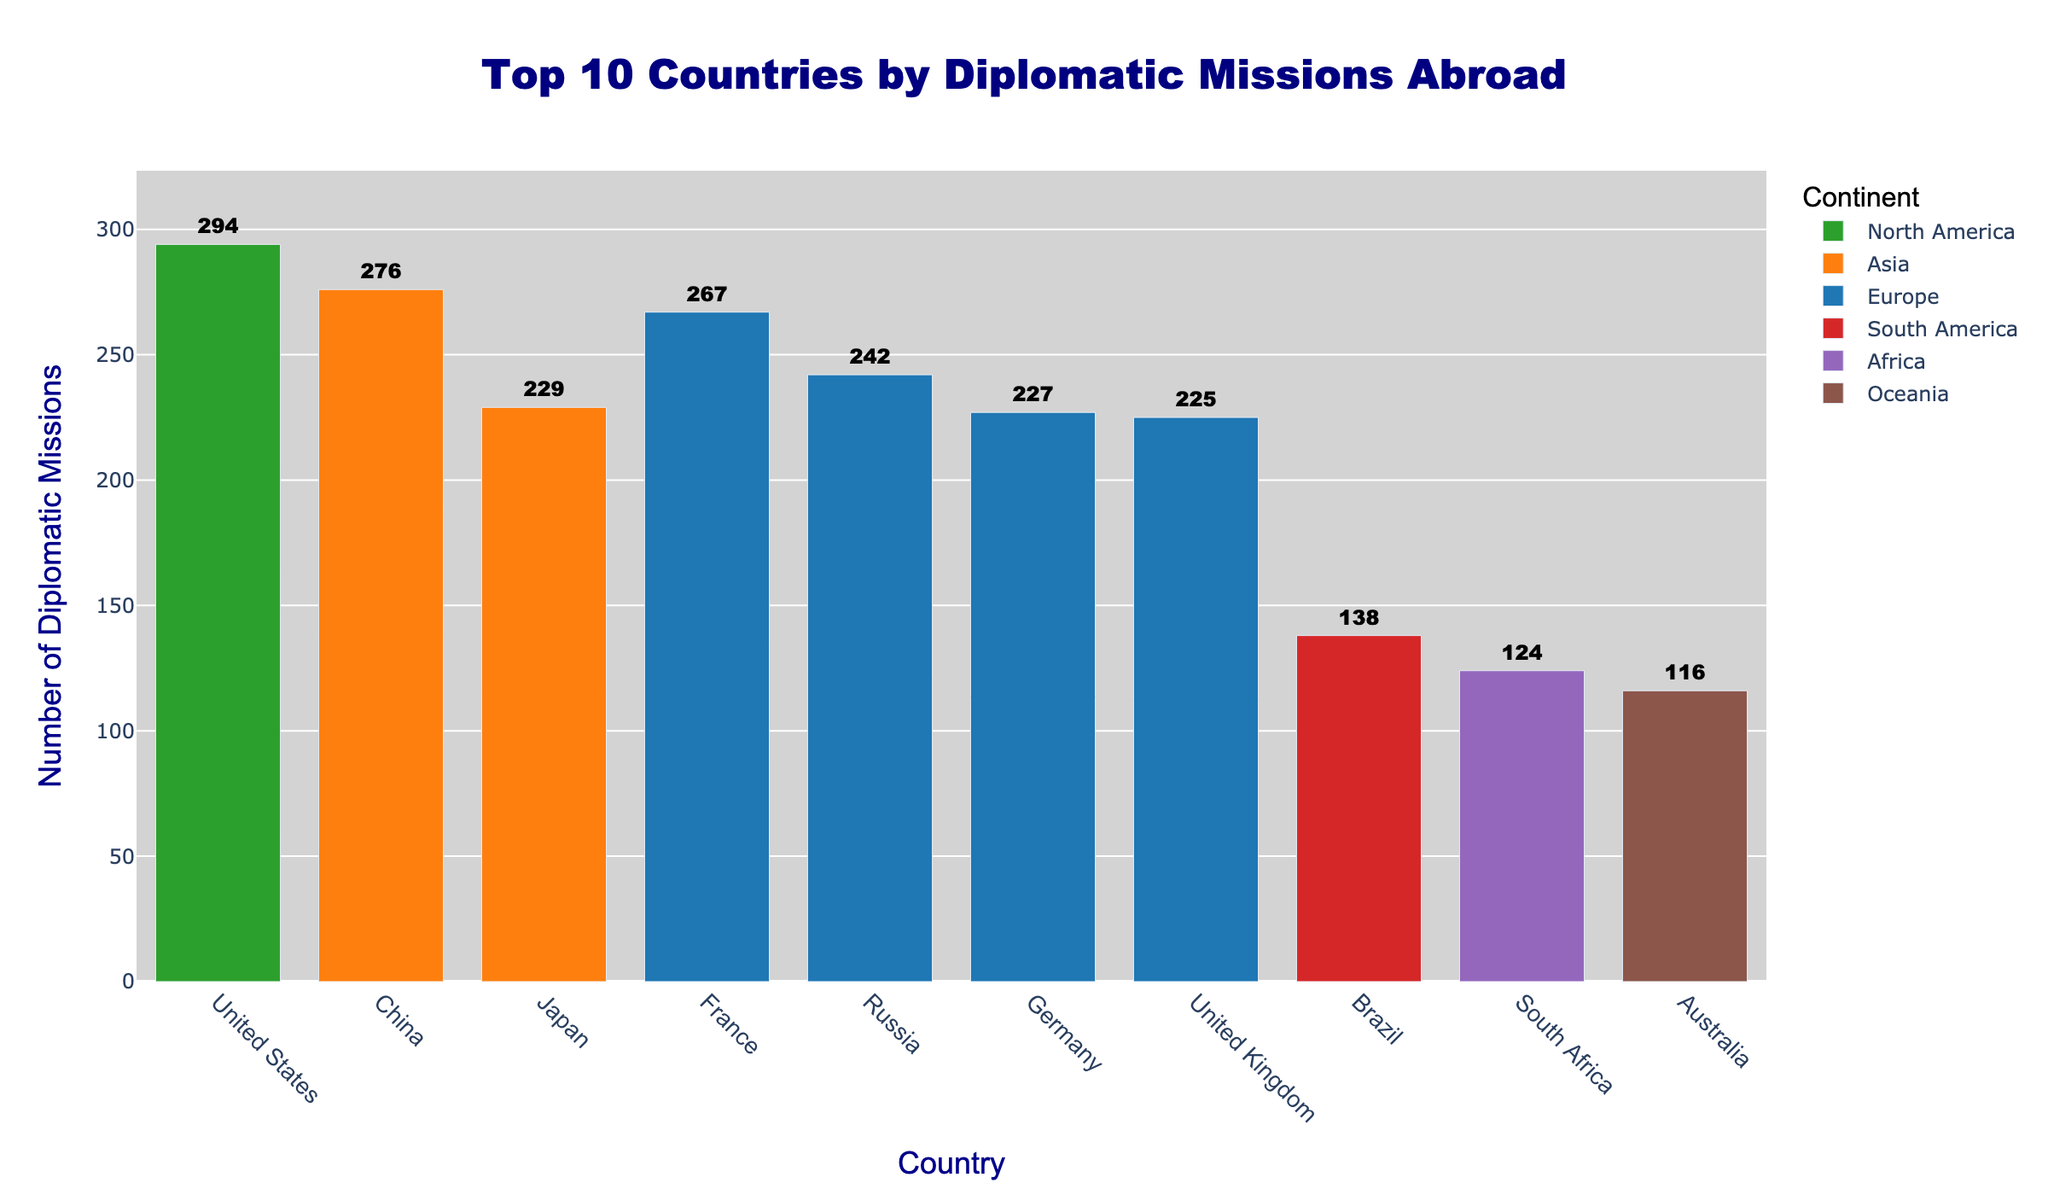Which country has the highest number of diplomatic missions abroad? The figure shows the number of diplomatic missions for each country. The country with the highest bar represents the highest number. In this case, it is the United States with 294 diplomatic missions.
Answer: United States Which continent has the most countries listed in this top 10 chart? Count the number of countries listed for each continent in the top 10. Europe has four countries (France, the United Kingdom, Russia, and Germany) listed, which is more than any other continent.
Answer: Europe How many diplomatic missions do France, Germany, and the United Kingdom have in total? Add the number of diplomatic missions for France (267), Germany (227), and the United Kingdom (225). 267 + 227 + 225 = 719.
Answer: 719 Which country has fewer diplomatic missions abroad, South Africa or Australia? Compare the number of diplomatic missions for South Africa (124) and Australia (116). Australia has fewer diplomatic missions than South Africa.
Answer: Australia What is the difference in the number of diplomatic missions between China and Brazil? Subtract the number of diplomatic missions for Brazil (138) from China (276). 276 - 138 = 138.
Answer: 138 Which Asian country has more diplomatic missions abroad, China or Japan? Compare the number of diplomatic missions for China (276) and Japan (229). China has more diplomatic missions than Japan.
Answer: China Which continent is represented by the green color in the bar chart? Identify the color associated with each continent. The green color represents North America.
Answer: North America Calculate the average number of diplomatic missions for the countries on the chart. Add the number of diplomatic missions for all countries and divide by the total number of countries. (294 + 276 + 267 + 242 + 229 + 227 + 225 + 138 + 124 + 116) / 10 = 2338 / 10 = 233.8.
Answer: 233.8 How many more diplomatic missions does the United States have compared to Russia? Subtract the number of diplomatic missions of Russia (242) from the United States (294). 294 - 242 = 52.
Answer: 52 Which country in the Southern Hemisphere has the highest number of diplomatic missions? Identify countries in the Southern Hemisphere from the chart (Brazil, South Africa, and Australia), then compare their number of diplomatic missions. Brazil has the highest with 138.
Answer: Brazil 